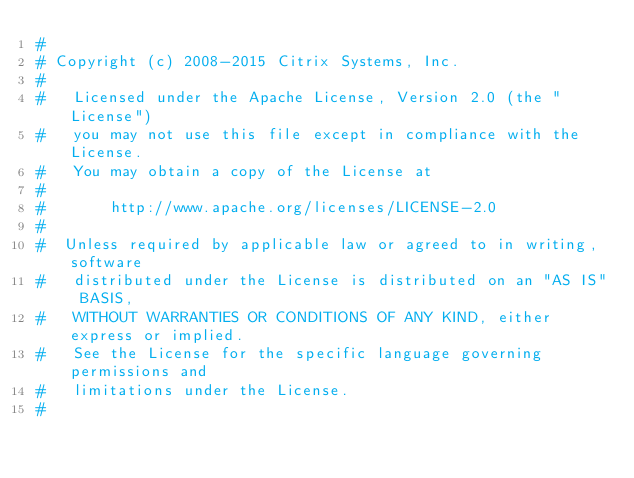<code> <loc_0><loc_0><loc_500><loc_500><_Python_>#
# Copyright (c) 2008-2015 Citrix Systems, Inc.
#
#   Licensed under the Apache License, Version 2.0 (the "License")
#   you may not use this file except in compliance with the License.
#   You may obtain a copy of the License at
#
#       http://www.apache.org/licenses/LICENSE-2.0
#
#  Unless required by applicable law or agreed to in writing, software
#   distributed under the License is distributed on an "AS IS" BASIS,
#   WITHOUT WARRANTIES OR CONDITIONS OF ANY KIND, either express or implied.
#   See the License for the specific language governing permissions and
#   limitations under the License.
#
</code> 